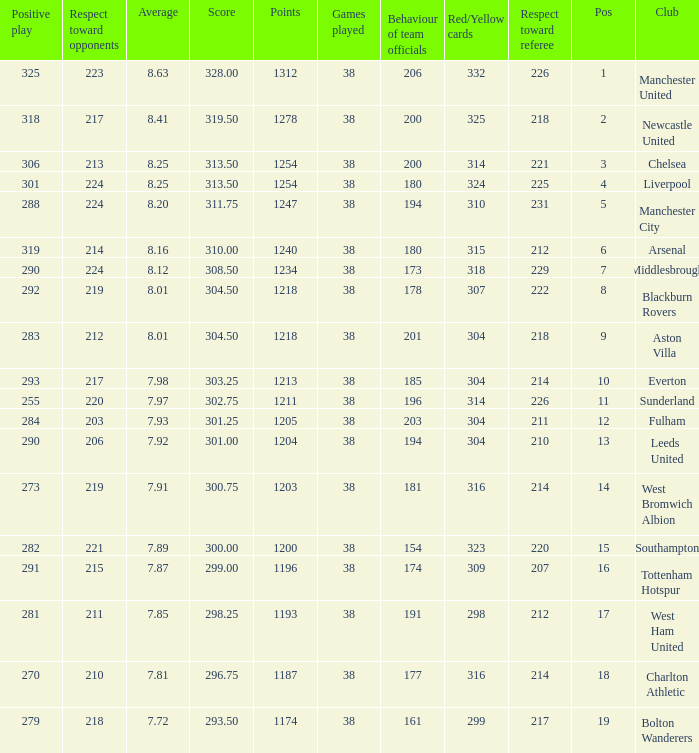Name the most red/yellow cards for positive play being 255 314.0. 